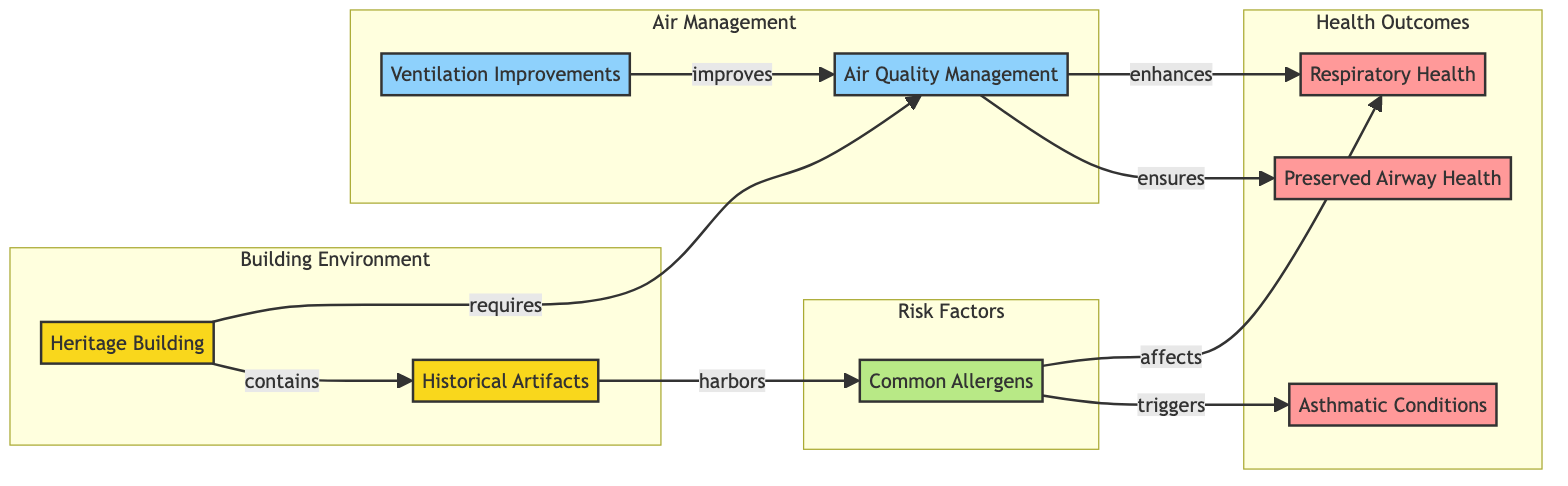What is the main object represented in the diagram? The main object in the diagram is the Heritage Building, which is indicated as the starting point of various connections in the flow.
Answer: Heritage Building How many health outcomes are depicted in the diagram? The diagram shows three health outcomes: Respiratory Health, Asthmatic Conditions, and Preserved Airway Health. Counting these gives a total of three outcomes.
Answer: 3 Which process directly affects Respiratory Health? The process that directly affects Respiratory Health is Air Quality Management, as indicated by the arrow leading from AQM to RH.
Answer: Air Quality Management What triggers Asthmatic Conditions according to the diagram? Common Allergens are indicated to trigger Asthmatic Conditions, shown by the arrow connecting CA and AC.
Answer: Common Allergens What is the relationship between Ventilation Improvements and Air Quality Management? Ventilation Improvements lead to improvements in Air Quality Management, as expressed by the arrow showing VI improving AQM.
Answer: improves How does Air Quality Management ensure Preserved Airway Health? The diagram indicates that Air Quality Management ensures Preserved Airway Health through a direct connection between AQM and PAH, showing a causal relationship.
Answer: ensures Name one factor that affects Respiratory Health. The diagram specifies Common Allergens as affecting Respiratory Health, which is represented by the arrow from CA to RH.
Answer: Common Allergens List one object that contains Historical Artifacts. The Heritage Building is the object that contains Historical Artifacts as indicated by the connection from HB to HA.
Answer: Heritage Building What is the subgraph label for the risk factors in the diagram? The subgraph that contains the risk factors is labeled as "Risk Factors," which is indicated in the diagram layout.
Answer: Risk Factors 